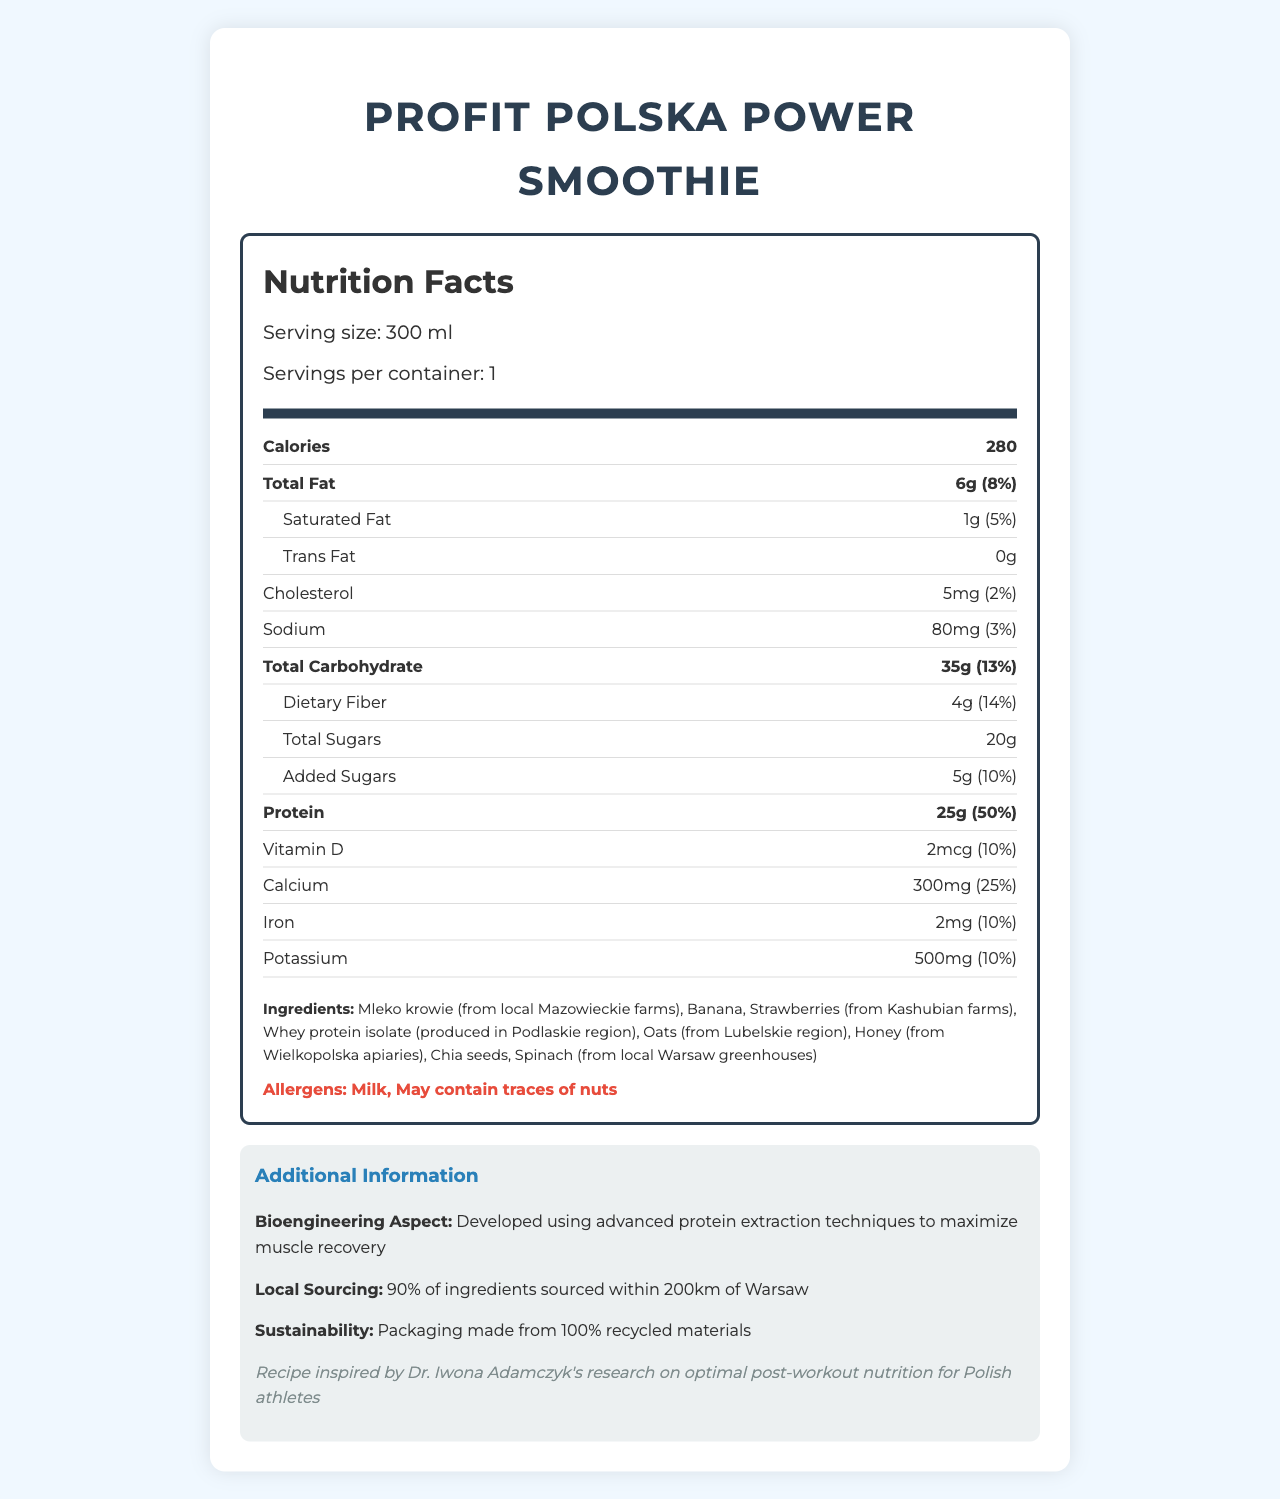what is the serving size of ProFit Polska Power Smoothie? The serving size is explicitly mentioned in the section "Serving size: 300 ml".
Answer: 300 ml how many grams of protein does one serving contain? The amount of protein per serving is listed as "25g" in the nutrition facts.
Answer: 25g which ingredient in the ProFit Polska Power Smoothie comes from Lubelskie region? The ingredients section lists "Oats (from Lubelskie region)".
Answer: Oats how many calories are there in one serving? The calories per serving are listed as "280" in the nutrition label.
Answer: 280 what percentage of the daily value for calcium does one serving provide? The daily value percentage for calcium is provided as "25%" in the nutrition label.
Answer: 25% what is the total carbohydrate content? A. 13g B. 25g C. 35g D. 50g The total carbohydrate content for one serving is listed as "Total Carbohydrate: 35g (13%)".
Answer: C. 35g which ingredient is sourced from local Warsaw greenhouses? A. Banana B. Honey C. Spinach D. Whey protein isolate The ingredients section specifies that Spinach is sourced from local Warsaw greenhouses.
Answer: C. Spinach is there any trans fat in the ProFit Polska Power Smoothie? The nutrition label states that the trans fat content is "0g".
Answer: No summarize the main idea of the document The document provides detailed nutritional information, highlights the local and sustainable sourcing of ingredients, and underscores the product's bioengineering aspects aimed at muscle recovery.
Answer: The ProFit Polska Power Smoothie is a protein-rich post-workout recovery drink. It features locally sourced ingredients, and contains 280 calories per serving with high levels of protein, calcium, and other essential nutrients. The smoothie includes natural ingredients from various Polish regions, supports sustainable practices, and is inspired by Dr. Iwona Adamczyk's research. how was the advanced protein extraction technique used in this smoothie beneficial? The document mentions the use of advanced protein extraction techniques but does not provide specific details on their benefits or methods.
Answer: Not enough information what are the allergens listed? The allergens are explicitly mentioned as "Milk" and "May contain traces of nuts" in the allergens section.
Answer: Milk, May contain traces of nuts how many grams of dietary fiber does the smoothie contain? The nutrition label shows that the dietary fiber content per serving is "4g (14%)".
Answer: 4g which region produces the whey protein isolate used in the smoothie? The whey protein isolate is sourced from the Podlaskie region as mentioned in the ingredients list.
Answer: Podlaskie what are the total sugars included in the smoothie? The total sugar content is listed as "Total Sugars: 20g" in the nutrition label.
Answer: 20g what percentage of daily calcium needs does one ProFit Polska Power Smoothie provide? A. 10% B. 25% C. 50% The document lists the calcium percentage as "25%" in the nutrition facts.
Answer: B. 25% of the listed ingredients, which two come from apiaries and farms? The ingredients section mentions "Honey (from Wielkopolska apiaries)" and "Strawberries (from Kashubian farms)".
Answer: Honey, Strawberries 